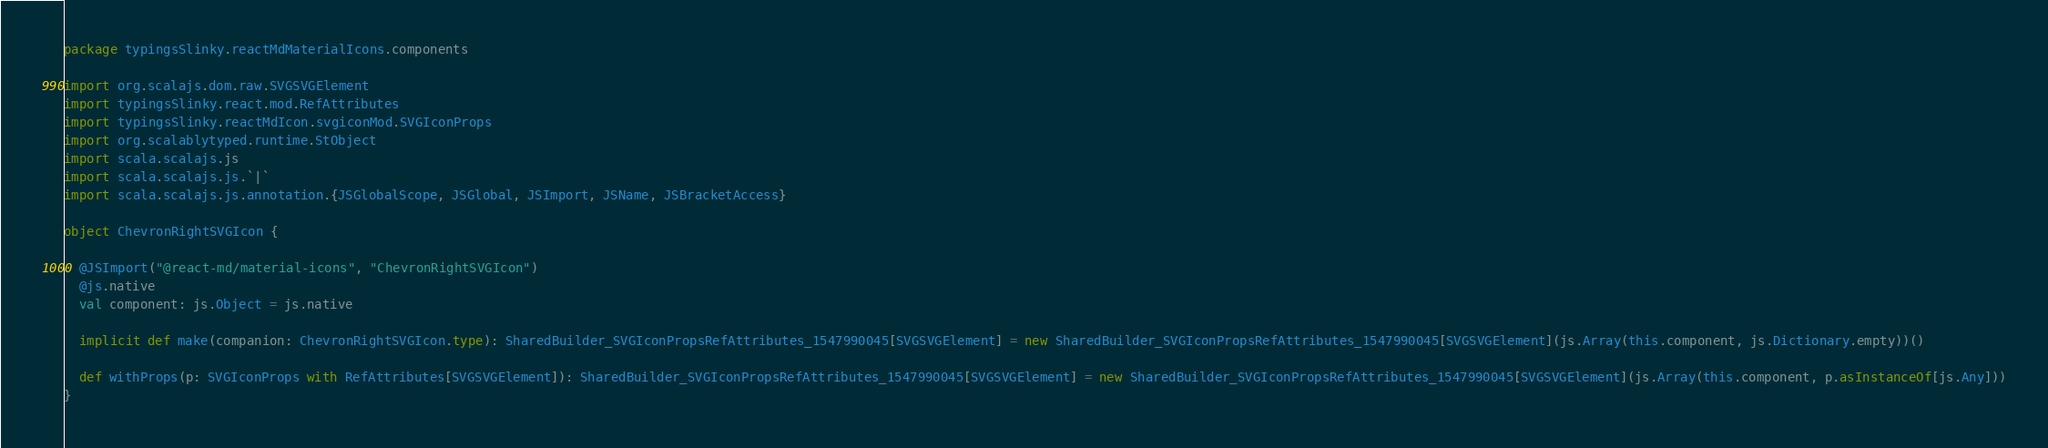Convert code to text. <code><loc_0><loc_0><loc_500><loc_500><_Scala_>package typingsSlinky.reactMdMaterialIcons.components

import org.scalajs.dom.raw.SVGSVGElement
import typingsSlinky.react.mod.RefAttributes
import typingsSlinky.reactMdIcon.svgiconMod.SVGIconProps
import org.scalablytyped.runtime.StObject
import scala.scalajs.js
import scala.scalajs.js.`|`
import scala.scalajs.js.annotation.{JSGlobalScope, JSGlobal, JSImport, JSName, JSBracketAccess}

object ChevronRightSVGIcon {
  
  @JSImport("@react-md/material-icons", "ChevronRightSVGIcon")
  @js.native
  val component: js.Object = js.native
  
  implicit def make(companion: ChevronRightSVGIcon.type): SharedBuilder_SVGIconPropsRefAttributes_1547990045[SVGSVGElement] = new SharedBuilder_SVGIconPropsRefAttributes_1547990045[SVGSVGElement](js.Array(this.component, js.Dictionary.empty))()
  
  def withProps(p: SVGIconProps with RefAttributes[SVGSVGElement]): SharedBuilder_SVGIconPropsRefAttributes_1547990045[SVGSVGElement] = new SharedBuilder_SVGIconPropsRefAttributes_1547990045[SVGSVGElement](js.Array(this.component, p.asInstanceOf[js.Any]))
}
</code> 